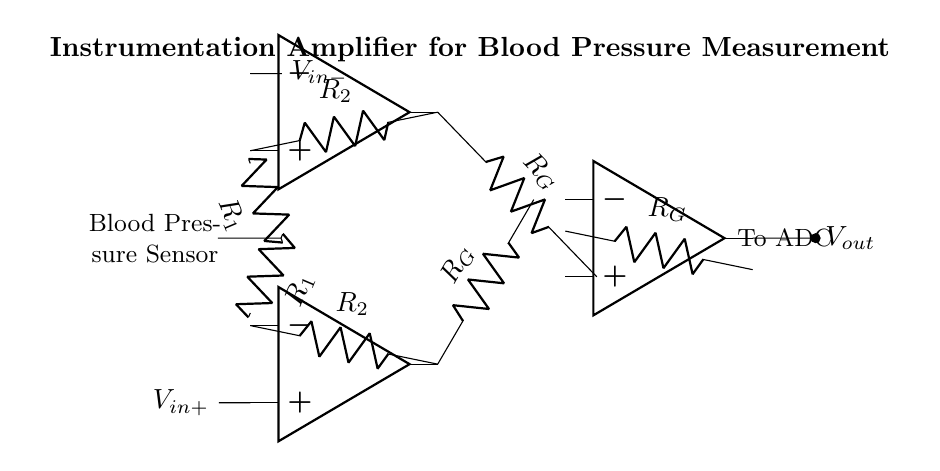What is the function of the op-amps in this circuit? The op-amps amplify the differential input signals from the blood pressure sensor, enabling precise measurement.
Answer: Amplification What type of circuit is depicted? This circuit is an instrumentation amplifier specifically designed for precise measurements.
Answer: Instrumentation amplifier How many resistors are used in the circuit? There are three different resistors labeled R1, R2, and RG used in the circuit for signal conditioning and gain settings.
Answer: Three Where does the output of the amplifier connect? The output node connects to an Analog-to-Digital Converter (ADC) for further processing of the amplified signal.
Answer: To ADC What do R1 and R2 represent in the circuit? R1 and R2 are gain-setting resistors that help define the amplification factor of the instrumentation amplifier.
Answer: Gain-setting resistors What is the role of RG in the circuit? RG is the gain resistor responsible for setting the gain of the output signal based on the input differential voltage.
Answer: Gain resistor 